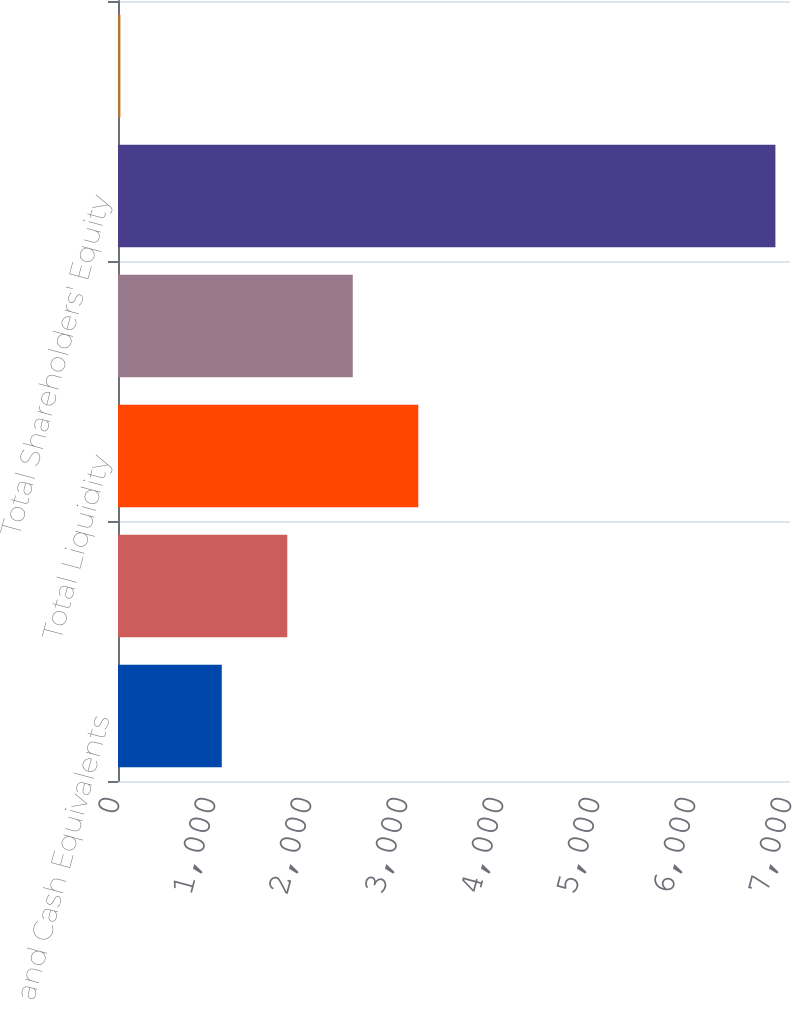<chart> <loc_0><loc_0><loc_500><loc_500><bar_chart><fcel>Cash and Cash Equivalents<fcel>Amount Available to be<fcel>Total Liquidity<fcel>Total Debt (2)<fcel>Total Shareholders' Equity<fcel>Ratio of Debt-to-Book Capital<nl><fcel>1081<fcel>1763.3<fcel>3127.9<fcel>2445.6<fcel>6848<fcel>25<nl></chart> 